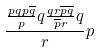Convert formula to latex. <formula><loc_0><loc_0><loc_500><loc_500>\frac { \frac { p q p \overline { q } } { p } q \frac { q r \overline { p } \overline { q } } { \overline { p } r } q } { r } p</formula> 